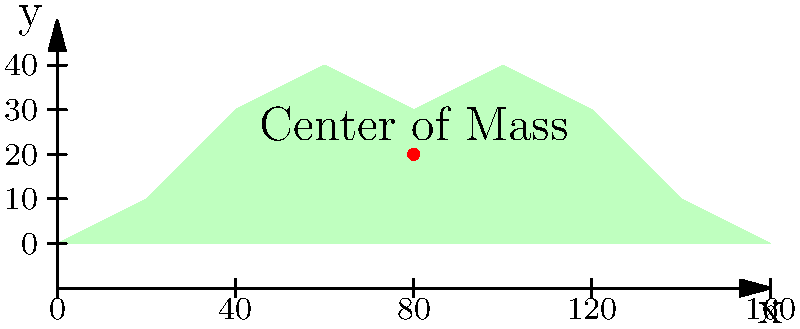The image shows an irregularly shaped object resembling the map of Myanmar. If the object has a uniform density, where would its center of mass be located approximately? Express your answer as coordinates $(x, y)$ in the given coordinate system. To determine the center of mass of an irregularly shaped object with uniform density, we can follow these steps:

1) For a uniformly dense object, the center of mass coincides with the geometric center (centroid) of the shape.

2) For irregular shapes, we can estimate the centroid visually by finding the point that would balance the object if it were placed on a pin.

3) Looking at the shape:
   - It's roughly symmetrical left to right, suggesting the x-coordinate of the center of mass would be near the middle of the x-axis.
   - It's more elongated in the upper half, suggesting the y-coordinate would be slightly above the middle of the y-axis.

4) The x-axis extends from 0 to 160 units. The middle would be at 80 units.

5) The y-axis extends from 0 to 40 units. Considering the elongation in the upper half, we can estimate the y-coordinate to be around 20 units.

6) The red dot in the image confirms this estimation, placed at approximately (80, 20).

Therefore, we can conclude that the center of mass is located at approximately (80, 20) in the given coordinate system.
Answer: $(80, 20)$ 